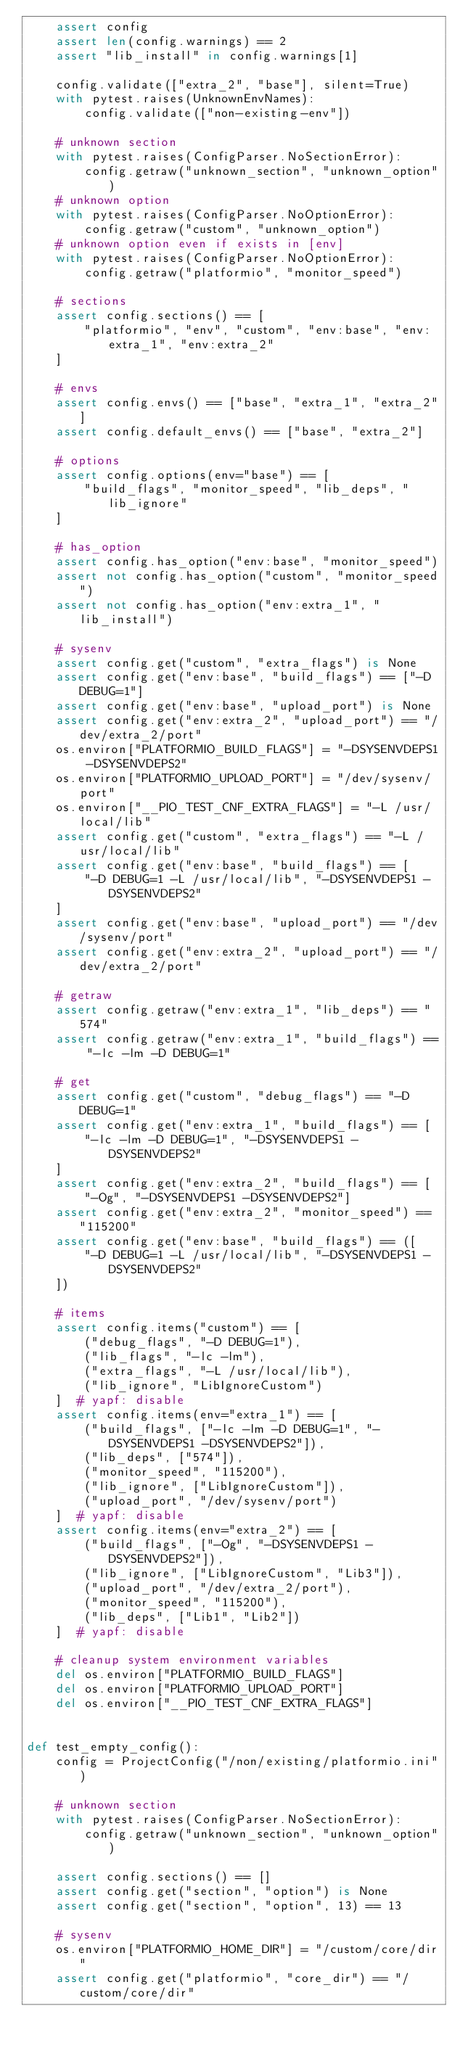<code> <loc_0><loc_0><loc_500><loc_500><_Python_>    assert config
    assert len(config.warnings) == 2
    assert "lib_install" in config.warnings[1]

    config.validate(["extra_2", "base"], silent=True)
    with pytest.raises(UnknownEnvNames):
        config.validate(["non-existing-env"])

    # unknown section
    with pytest.raises(ConfigParser.NoSectionError):
        config.getraw("unknown_section", "unknown_option")
    # unknown option
    with pytest.raises(ConfigParser.NoOptionError):
        config.getraw("custom", "unknown_option")
    # unknown option even if exists in [env]
    with pytest.raises(ConfigParser.NoOptionError):
        config.getraw("platformio", "monitor_speed")

    # sections
    assert config.sections() == [
        "platformio", "env", "custom", "env:base", "env:extra_1", "env:extra_2"
    ]

    # envs
    assert config.envs() == ["base", "extra_1", "extra_2"]
    assert config.default_envs() == ["base", "extra_2"]

    # options
    assert config.options(env="base") == [
        "build_flags", "monitor_speed", "lib_deps", "lib_ignore"
    ]

    # has_option
    assert config.has_option("env:base", "monitor_speed")
    assert not config.has_option("custom", "monitor_speed")
    assert not config.has_option("env:extra_1", "lib_install")

    # sysenv
    assert config.get("custom", "extra_flags") is None
    assert config.get("env:base", "build_flags") == ["-D DEBUG=1"]
    assert config.get("env:base", "upload_port") is None
    assert config.get("env:extra_2", "upload_port") == "/dev/extra_2/port"
    os.environ["PLATFORMIO_BUILD_FLAGS"] = "-DSYSENVDEPS1 -DSYSENVDEPS2"
    os.environ["PLATFORMIO_UPLOAD_PORT"] = "/dev/sysenv/port"
    os.environ["__PIO_TEST_CNF_EXTRA_FLAGS"] = "-L /usr/local/lib"
    assert config.get("custom", "extra_flags") == "-L /usr/local/lib"
    assert config.get("env:base", "build_flags") == [
        "-D DEBUG=1 -L /usr/local/lib", "-DSYSENVDEPS1 -DSYSENVDEPS2"
    ]
    assert config.get("env:base", "upload_port") == "/dev/sysenv/port"
    assert config.get("env:extra_2", "upload_port") == "/dev/extra_2/port"

    # getraw
    assert config.getraw("env:extra_1", "lib_deps") == "574"
    assert config.getraw("env:extra_1", "build_flags") == "-lc -lm -D DEBUG=1"

    # get
    assert config.get("custom", "debug_flags") == "-D DEBUG=1"
    assert config.get("env:extra_1", "build_flags") == [
        "-lc -lm -D DEBUG=1", "-DSYSENVDEPS1 -DSYSENVDEPS2"
    ]
    assert config.get("env:extra_2", "build_flags") == [
        "-Og", "-DSYSENVDEPS1 -DSYSENVDEPS2"]
    assert config.get("env:extra_2", "monitor_speed") == "115200"
    assert config.get("env:base", "build_flags") == ([
        "-D DEBUG=1 -L /usr/local/lib", "-DSYSENVDEPS1 -DSYSENVDEPS2"
    ])

    # items
    assert config.items("custom") == [
        ("debug_flags", "-D DEBUG=1"),
        ("lib_flags", "-lc -lm"),
        ("extra_flags", "-L /usr/local/lib"),
        ("lib_ignore", "LibIgnoreCustom")
    ]  # yapf: disable
    assert config.items(env="extra_1") == [
        ("build_flags", ["-lc -lm -D DEBUG=1", "-DSYSENVDEPS1 -DSYSENVDEPS2"]),
        ("lib_deps", ["574"]),
        ("monitor_speed", "115200"),
        ("lib_ignore", ["LibIgnoreCustom"]),
        ("upload_port", "/dev/sysenv/port")
    ]  # yapf: disable
    assert config.items(env="extra_2") == [
        ("build_flags", ["-Og", "-DSYSENVDEPS1 -DSYSENVDEPS2"]),
        ("lib_ignore", ["LibIgnoreCustom", "Lib3"]),
        ("upload_port", "/dev/extra_2/port"),
        ("monitor_speed", "115200"),
        ("lib_deps", ["Lib1", "Lib2"])
    ]  # yapf: disable

    # cleanup system environment variables
    del os.environ["PLATFORMIO_BUILD_FLAGS"]
    del os.environ["PLATFORMIO_UPLOAD_PORT"]
    del os.environ["__PIO_TEST_CNF_EXTRA_FLAGS"]


def test_empty_config():
    config = ProjectConfig("/non/existing/platformio.ini")

    # unknown section
    with pytest.raises(ConfigParser.NoSectionError):
        config.getraw("unknown_section", "unknown_option")

    assert config.sections() == []
    assert config.get("section", "option") is None
    assert config.get("section", "option", 13) == 13

    # sysenv
    os.environ["PLATFORMIO_HOME_DIR"] = "/custom/core/dir"
    assert config.get("platformio", "core_dir") == "/custom/core/dir"</code> 